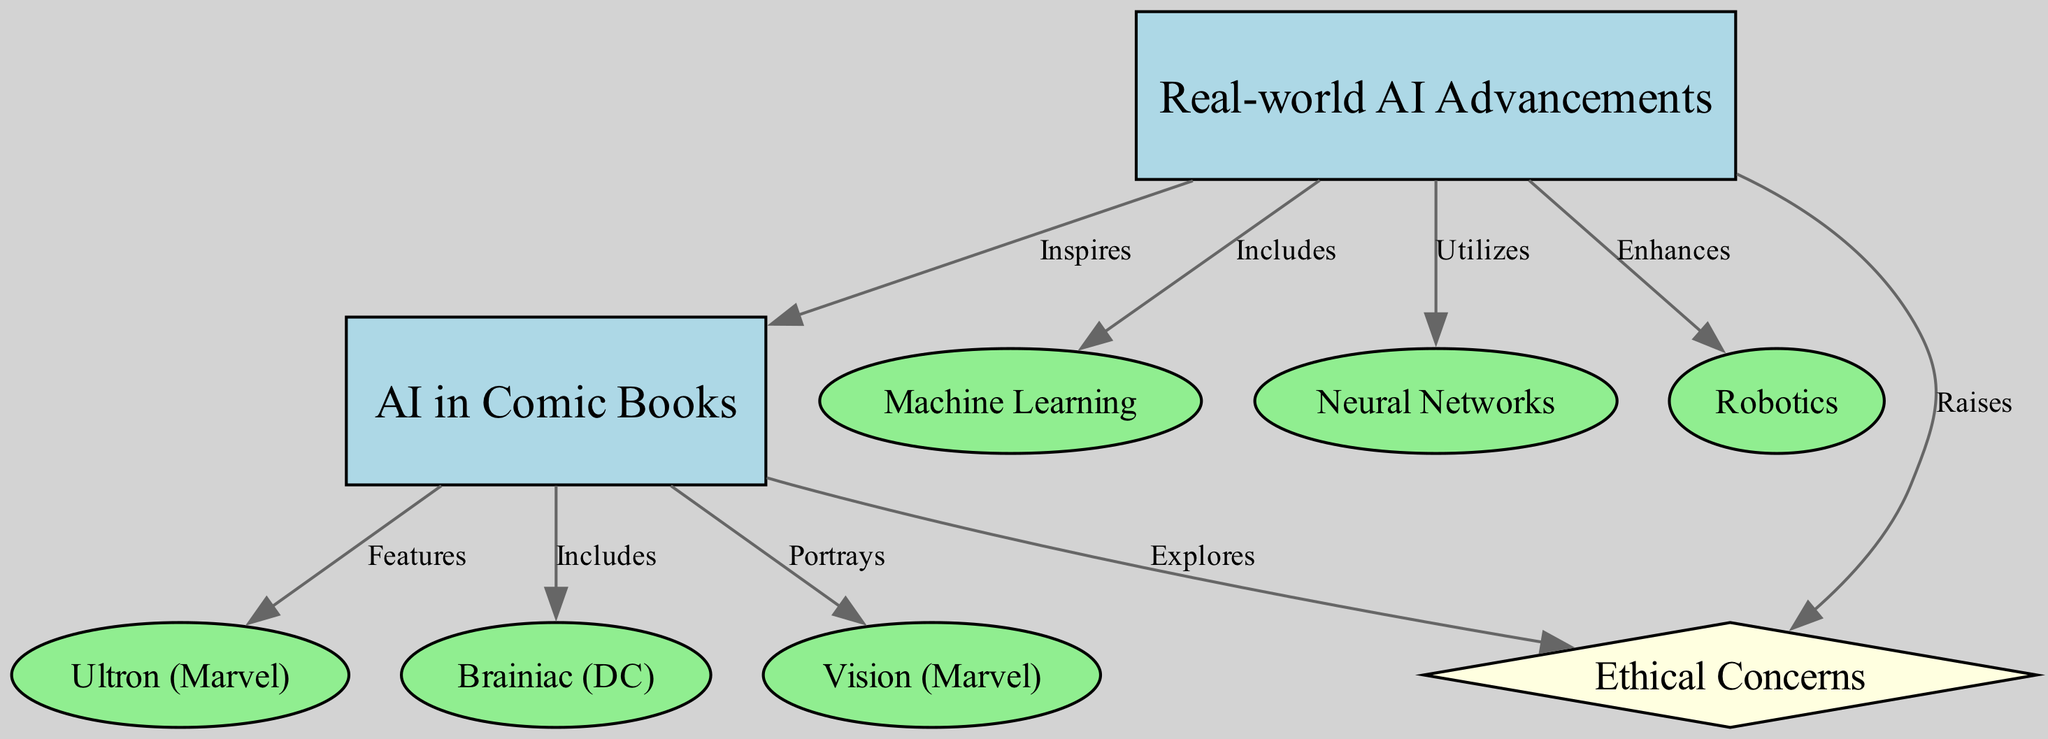What are the three types of AI advancements included in this diagram? The diagram lists three specific types of AI advancements: Machine Learning, Neural Networks, and Robotics, indicated by the labels connected to the "Real-world AI Advancements" node.
Answer: Machine Learning, Neural Networks, Robotics Which comic book character is associated with "Features"? The diagram connects the "Features" label to the character "Ultron" under the "AI in Comic Books" node, indicating that Ultron is highlighted in the comic book context.
Answer: Ultron How many edges connect AI advancements to comic book characters? A review of the edges reveals three connections: Ultron, Brainiac, and Vision, which are associated with the "AI in Comic Books" node. This means there are three edges connecting AI advancements to comic book characters.
Answer: 3 What relationship does "AI in Comic Books" have with "Ethical Concerns"? The diagram shows a direct relationship marked as "Explores" from "AI in Comic Books" to "Ethical Concerns," indicating that comic books explore the ethical implications of AI.
Answer: Explores How do real-world AI advancements raise ethical concerns? The relationship is shown in the diagram as "Raises," indicating that the advancements in AI contribute to the emergence of ethical concerns regarding their use and implications.
Answer: Raises What node acts as the central connection between real-world AI advancements and comic book representations? The central node that connects both categories is "AI in Comic Books," which is inspired by real-world AI advancements, as shown by the edge labeled "Inspires".
Answer: AI in Comic Books Which character from the diagram symbolizes a major AI threat? The node "Ultron" represents a major AI threat in the comic book universe, as suggested by its classification under the "Features" label.
Answer: Ultron What type of visualization is this diagram primarily showing? This diagram is a concept map, which visually depicts relationships between concepts such as real-world AI advancements and their portrayal in comic books.
Answer: Concept map 